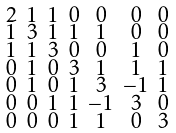Convert formula to latex. <formula><loc_0><loc_0><loc_500><loc_500>\begin{smallmatrix} 2 & 1 & 1 & 0 & 0 & 0 & 0 \\ 1 & 3 & 1 & 1 & 1 & 0 & 0 \\ 1 & 1 & 3 & 0 & 0 & 1 & 0 \\ 0 & 1 & 0 & 3 & 1 & 1 & 1 \\ 0 & 1 & 0 & 1 & 3 & - 1 & 1 \\ 0 & 0 & 1 & 1 & - 1 & 3 & 0 \\ 0 & 0 & 0 & 1 & 1 & 0 & 3 \end{smallmatrix}</formula> 